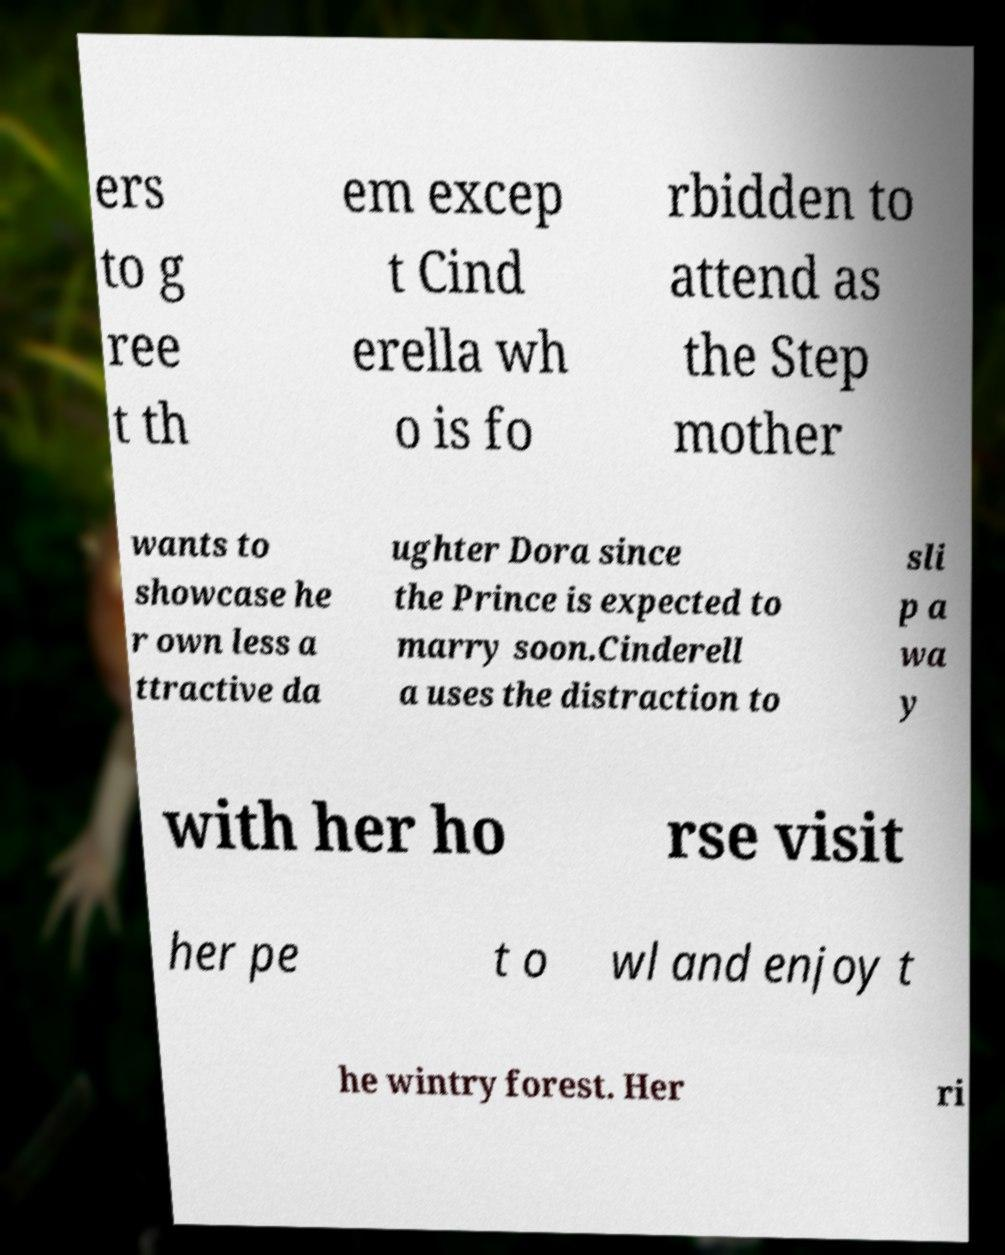Please read and relay the text visible in this image. What does it say? ers to g ree t th em excep t Cind erella wh o is fo rbidden to attend as the Step mother wants to showcase he r own less a ttractive da ughter Dora since the Prince is expected to marry soon.Cinderell a uses the distraction to sli p a wa y with her ho rse visit her pe t o wl and enjoy t he wintry forest. Her ri 